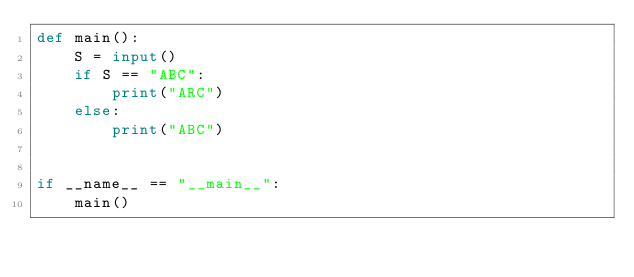Convert code to text. <code><loc_0><loc_0><loc_500><loc_500><_Python_>def main():
    S = input()
    if S == "ABC":
        print("ARC")
    else:
        print("ABC")


if __name__ == "__main__":
    main()
</code> 